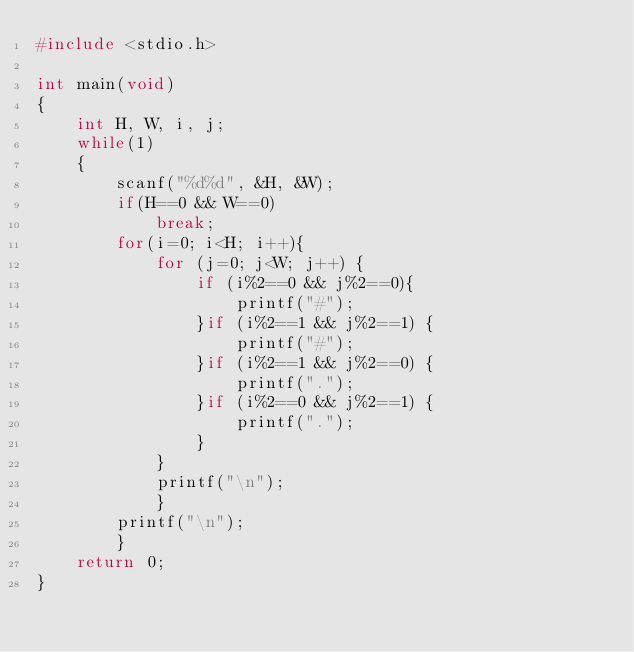<code> <loc_0><loc_0><loc_500><loc_500><_C_>#include <stdio.h>

int main(void)
{
    int H, W, i, j;
    while(1)
    {
        scanf("%d%d", &H, &W);
        if(H==0 && W==0)
            break;
        for(i=0; i<H; i++){
            for (j=0; j<W; j++) {
                if (i%2==0 && j%2==0){
                    printf("#");
                }if (i%2==1 && j%2==1) {
                    printf("#");
                }if (i%2==1 && j%2==0) {
                    printf(".");
                }if (i%2==0 && j%2==1) {
                    printf(".");
                }
            }
            printf("\n");
            }
        printf("\n");
        }
    return 0;
}</code> 